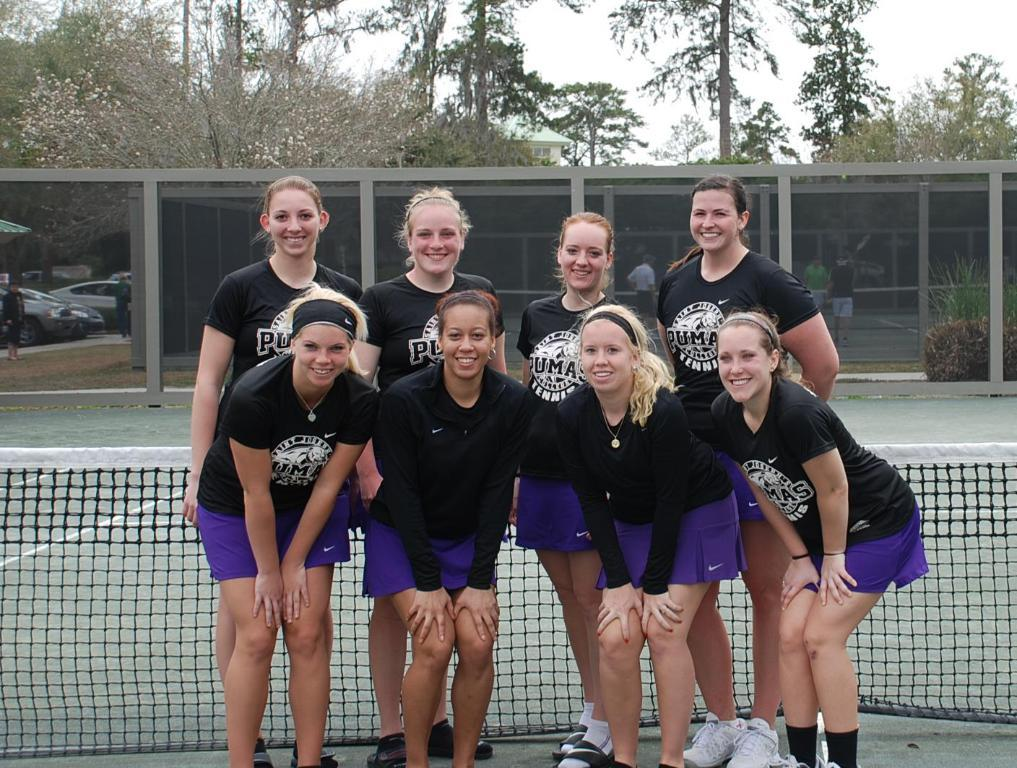<image>
Present a compact description of the photo's key features. Tennis players infront of a net with Puma Tennis on their shirt 